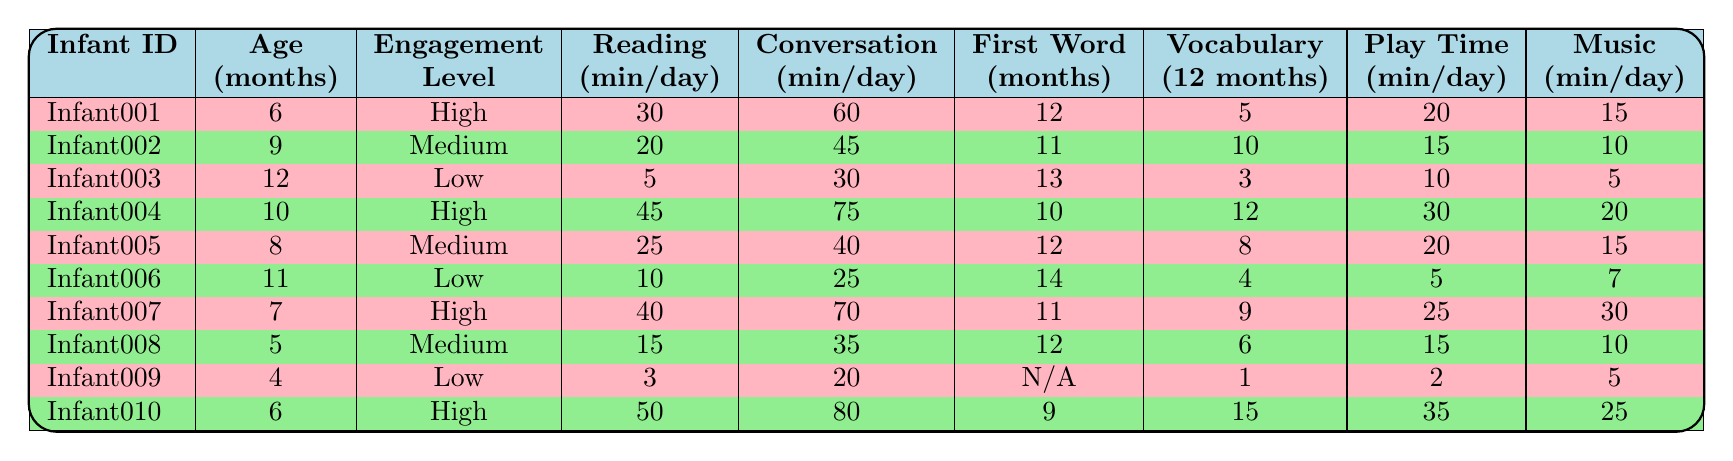What is the average daily reading time for infants with high parental engagement? There are three infants with high parental engagement (Infant001, Infant004, and Infant007). Their daily reading times are 30, 45, and 40 minutes respectively. The sum is 30 + 45 + 40 = 115. The average is 115/3 = 38.33.
Answer: 38.33 What was the first word age for Infant002? Looking at Infant002 in the table, the first word age is listed as 11 months.
Answer: 11 months Is there a correlation between parent engagement level and vocabulary size at age 12 months? Infant001, Infant004, and Infant007 have high engagement with vocabulary sizes of 5, 12, and 9. Infants with medium engagement (Infant002 and Infant005) have sizes 10 and 8. Infants with low engagement (Infant003 and Infant006) have sizes 3 and 4, showing a trend where higher engagement correlates with larger vocabulary sizes.
Answer: Yes Which infant had the most daily conversation time? Checking the conversation times, Infant010 had the highest daily conversation time of 80 minutes.
Answer: Infant010 What is the total daily interactive play time for infants with low parental engagement? There are two infants with low engagement: Infant003 and Infant006, whose interactive play times are 10 and 5 minutes respectively. Adding them gives 10 + 5 = 15 minutes.
Answer: 15 minutes Which infant first said their first word at 9 months? Looking at all the infants, none of them have a first word age of 9 months.
Answer: None What is the total daily reading time for all infants? Adding the daily reading times of all infants: 30 + 20 + 5 + 45 + 25 + 10 + 40 + 15 + 3 + 50 results in a total of 5 + 15 + 45 + 25 + 10 + 40 + 15 + 3 + 50 = 325 minutes.
Answer: 325 minutes How many infants have a vocabulary size greater than 10? Analyzing the vocabulary sizes, only Infant002 (10) and Infant004 (12) qualify with sizes equal to or below 10. Thus, only one infant (Infant004) has a vocabulary size greater than 10.
Answer: 1 What is the trend between age and first word age? Analyzing the ages and their corresponding first word ages: Infants are aged 4, 5, 6, 7, 8, 9, 10, 11, and 12 months with first word ages of N/A, 12, 12, 11, 12, 14, 10, 11, 11, and 9 respectively. There is no clear trend since the first word age fluctuates without a consistent pattern.
Answer: No clear trend Does more daily conversation time lead to earlier first word age? Comparing conversation times and first word ages: Infants with more conversation time like Infant010 (80 min, first word at 9 months) & Infant004 (75 min, first word at 10 months) do show earlier ages. However, Infant003 with only 30 minutes had a first word at 13 months, indicating other factors likely influence this.
Answer: No direct causation evident 